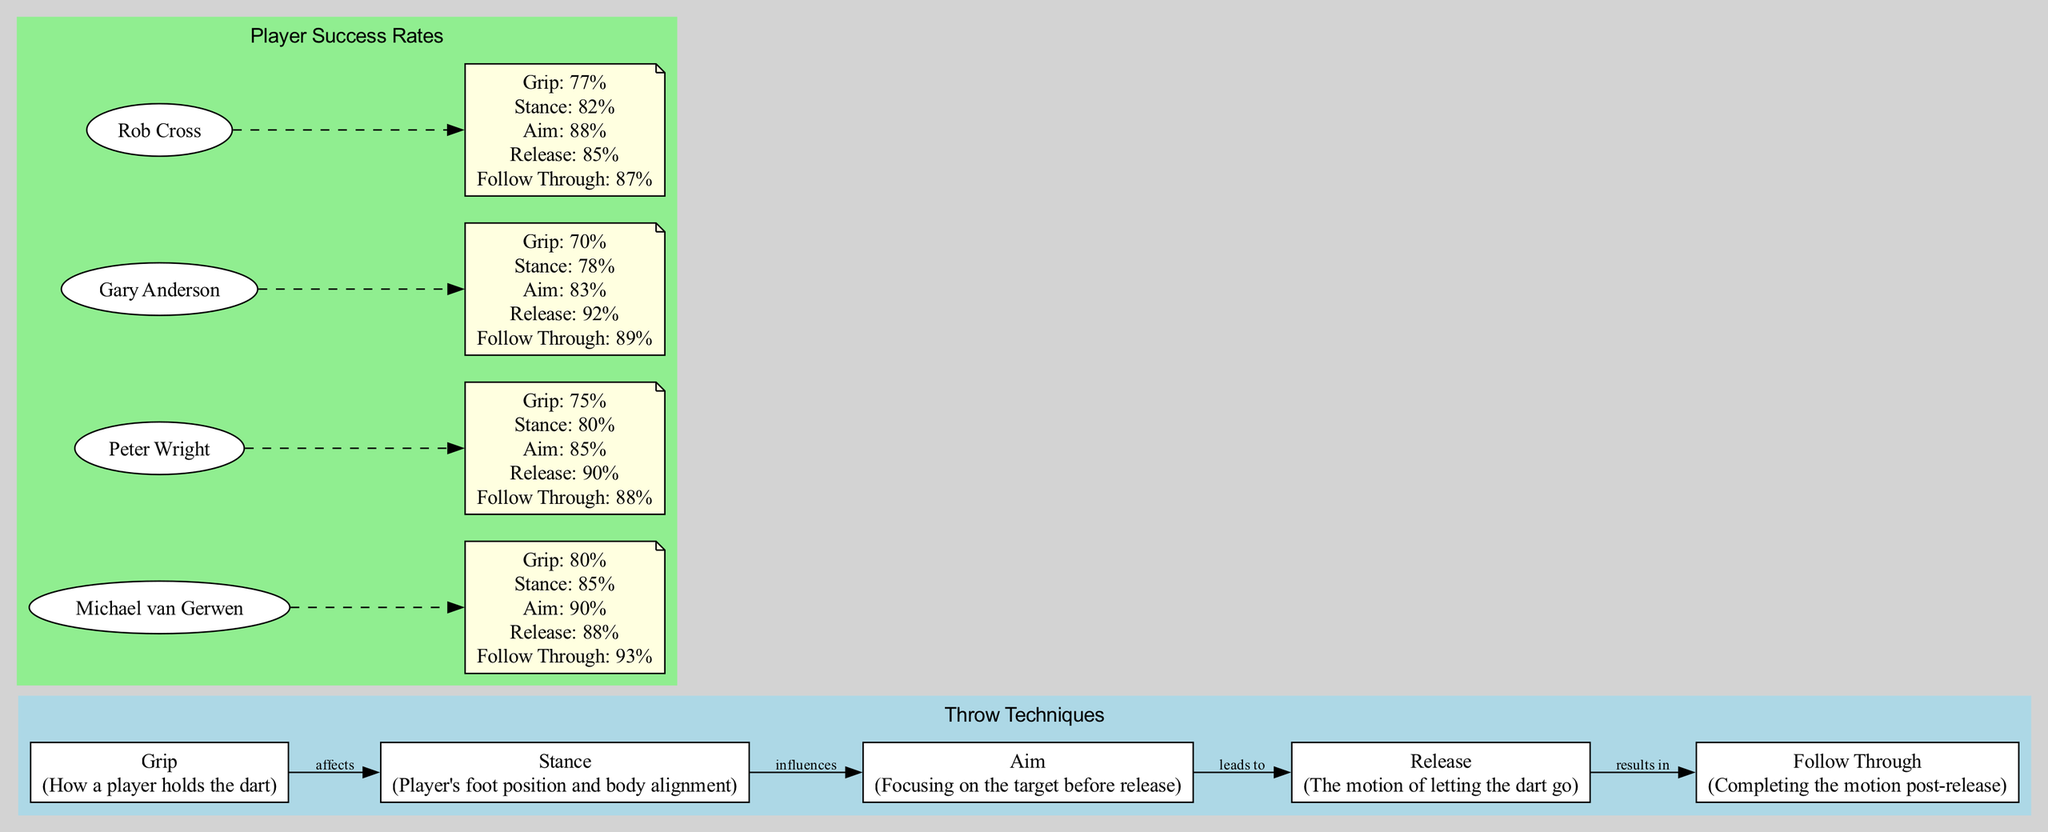What are the five techniques mentioned in the diagram? The diagram lists five techniques: Grip, Stance, Aim, Release, and Follow Through.
Answer: Grip, Stance, Aim, Release, Follow Through Which player has the highest follow-through success rate? By examining the success rates, Michael van Gerwen has a follow-through success rate of 93%, which is higher than the others.
Answer: Michael van Gerwen What is the relationship between stance and aim? The diagram shows that stance influences aim, indicating that how a player positions their feet and body affects their aiming ability.
Answer: influences Which player has the lowest grip success rate? Looking at the success rates, Gary Anderson has the lowest grip success rate at 70%.
Answer: Gary Anderson How many success rate metrics are provided for each player? Each player has five success rate metrics indicated for Grip, Stance, Aim, Release, and Follow Through, as shown in the respective section of the diagram.
Answer: Five What is the stance success rate of Rob Cross? From the diagram, Rob Cross has a stance success rate of 82%.
Answer: 82% Which throw technique leads to the release? The diagram illustrates that aim leads to release, showing the flow from aiming to the act of releasing the dart.
Answer: aim What is Peter Wright's success rate for the release technique? The diagram indicates that Peter Wright has a release success rate of 90%.
Answer: 90% 